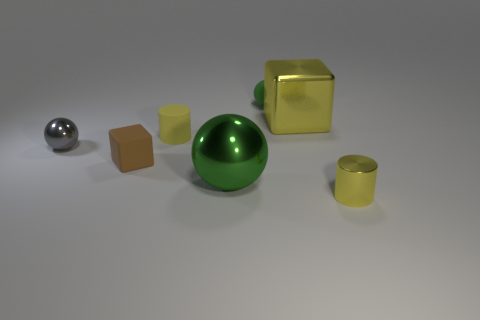Subtract all metallic balls. How many balls are left? 1 Add 2 tiny shiny cylinders. How many objects exist? 9 Subtract all brown cubes. How many cubes are left? 1 Subtract all spheres. How many objects are left? 4 Subtract all yellow cubes. How many purple spheres are left? 0 Subtract all small brown things. Subtract all tiny rubber objects. How many objects are left? 3 Add 4 tiny yellow objects. How many tiny yellow objects are left? 6 Add 4 tiny brown things. How many tiny brown things exist? 5 Subtract 0 cyan cylinders. How many objects are left? 7 Subtract 1 cylinders. How many cylinders are left? 1 